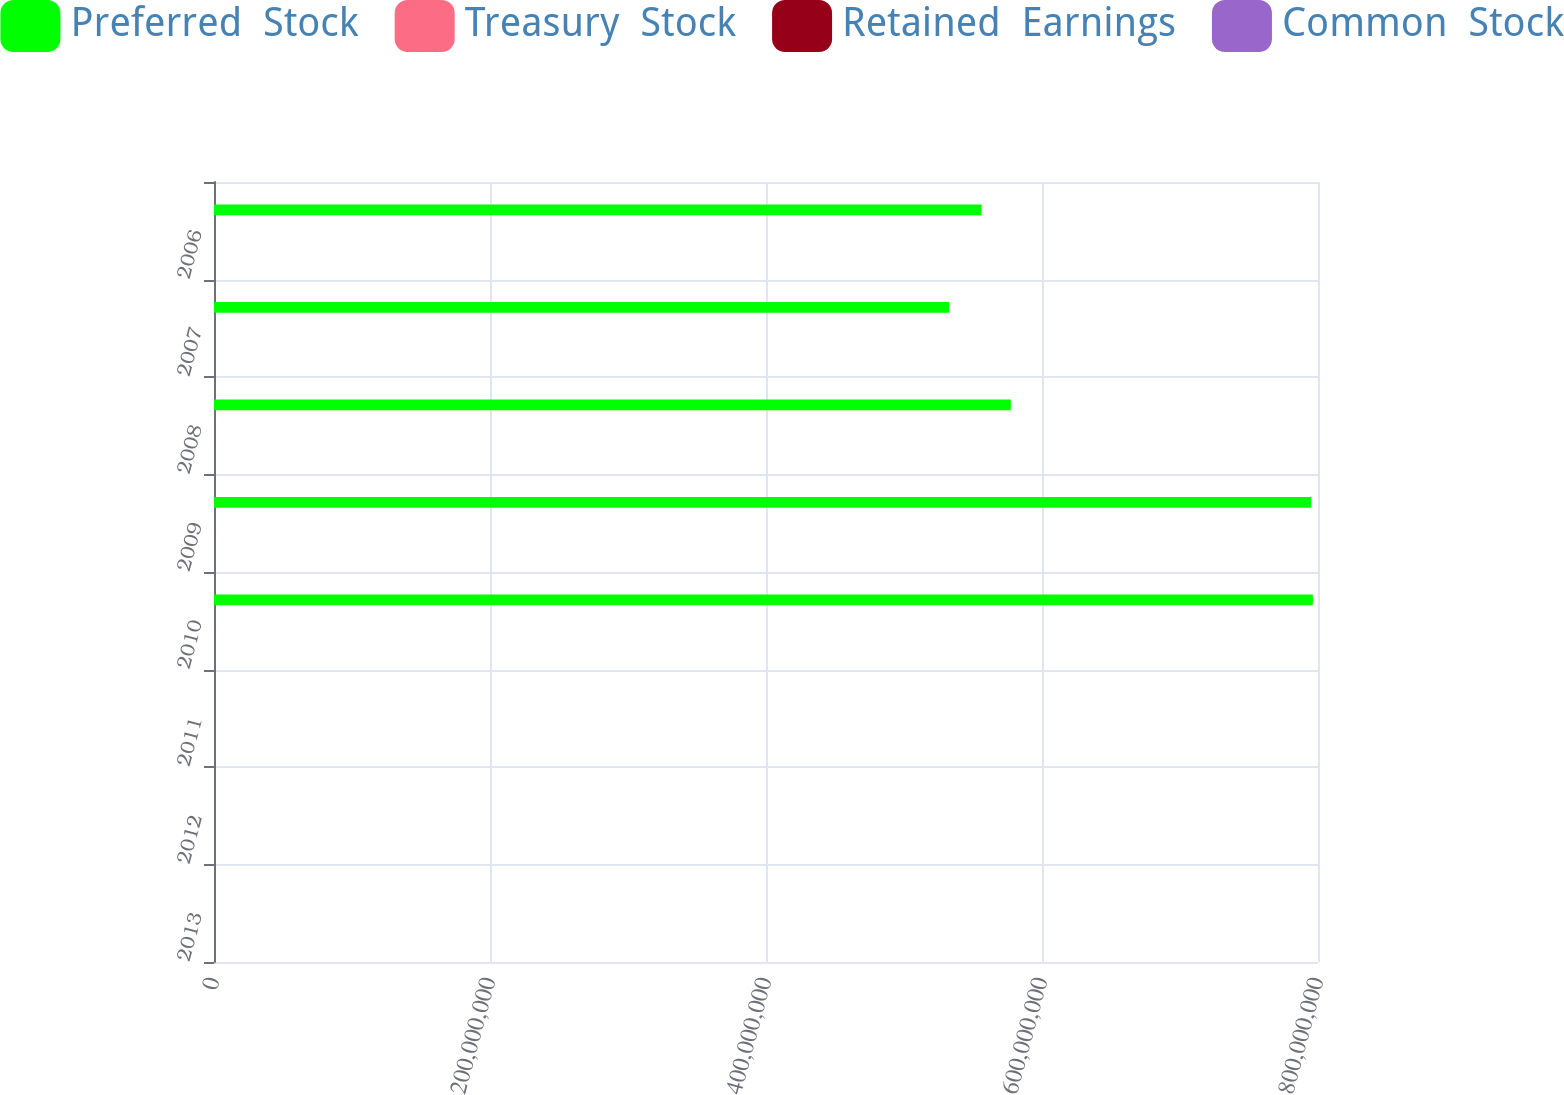Convert chart to OTSL. <chart><loc_0><loc_0><loc_500><loc_500><stacked_bar_chart><ecel><fcel>2013<fcel>2012<fcel>2011<fcel>2010<fcel>2009<fcel>2008<fcel>2007<fcel>2006<nl><fcel>Preferred  Stock<fcel>1812<fcel>1812<fcel>1812<fcel>7.96273e+08<fcel>7.95068e+08<fcel>5.77387e+08<fcel>5.32672e+08<fcel>5.56253e+08<nl><fcel>Treasury  Stock<fcel>2051<fcel>2051<fcel>2051<fcel>1779<fcel>1779<fcel>1295<fcel>1295<fcel>1295<nl><fcel>Retained  Earnings<fcel>1034<fcel>398<fcel>398<fcel>3654<fcel>3609<fcel>4241<fcel>9<fcel>9<nl><fcel>Common  Stock<fcel>2561<fcel>2758<fcel>2792<fcel>1715<fcel>1743<fcel>848<fcel>1779<fcel>1812<nl></chart> 